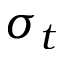<formula> <loc_0><loc_0><loc_500><loc_500>\sigma _ { t }</formula> 